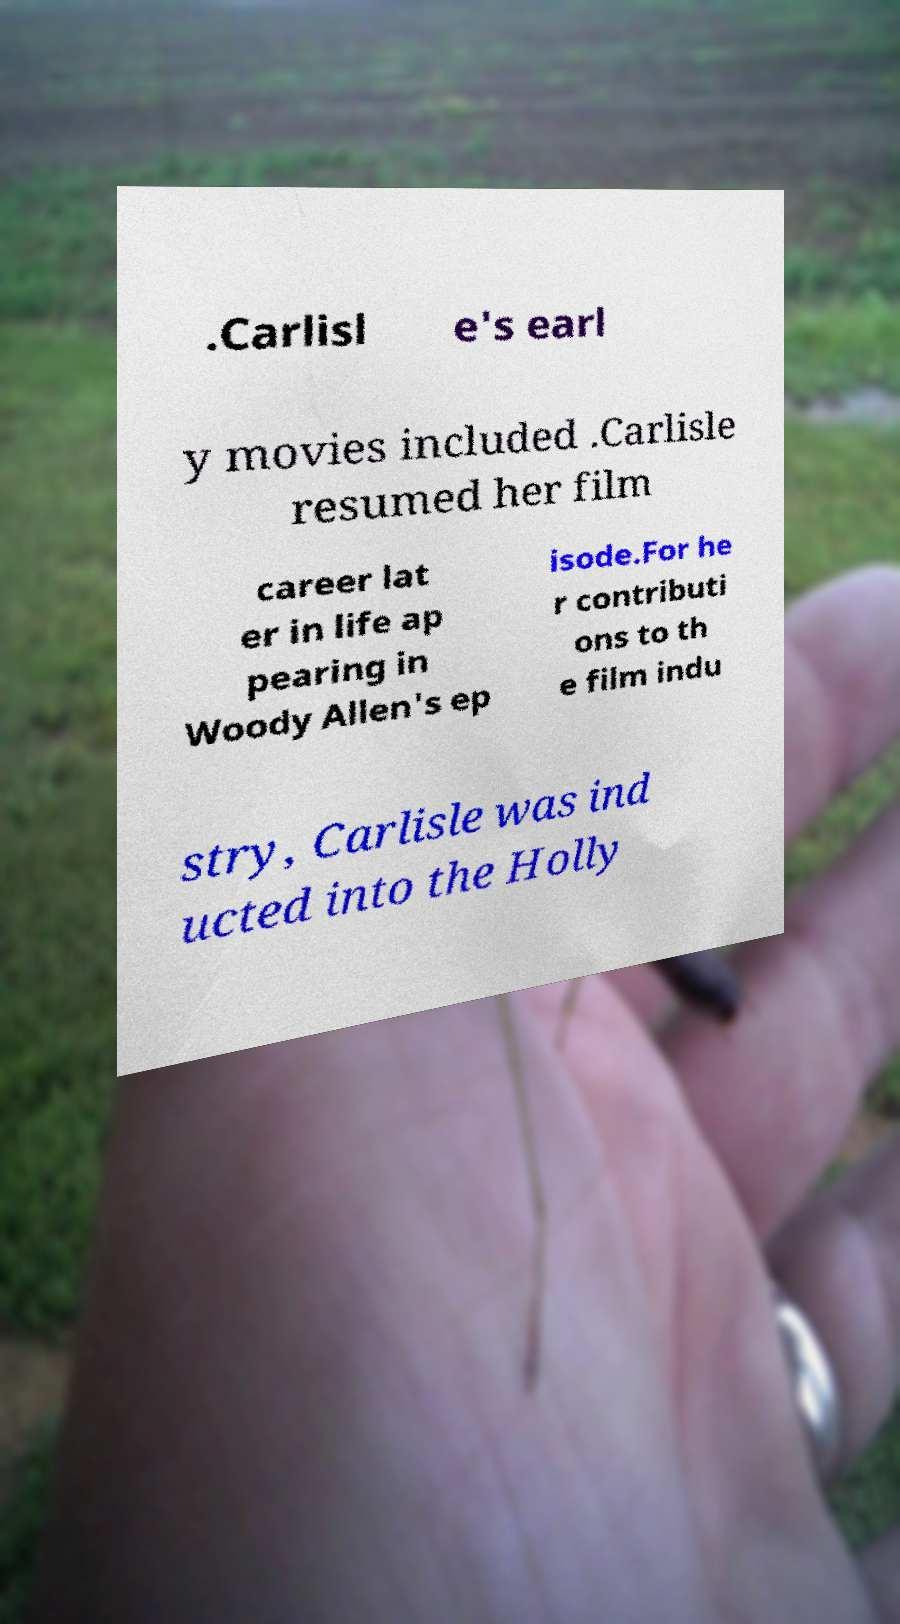I need the written content from this picture converted into text. Can you do that? .Carlisl e's earl y movies included .Carlisle resumed her film career lat er in life ap pearing in Woody Allen's ep isode.For he r contributi ons to th e film indu stry, Carlisle was ind ucted into the Holly 